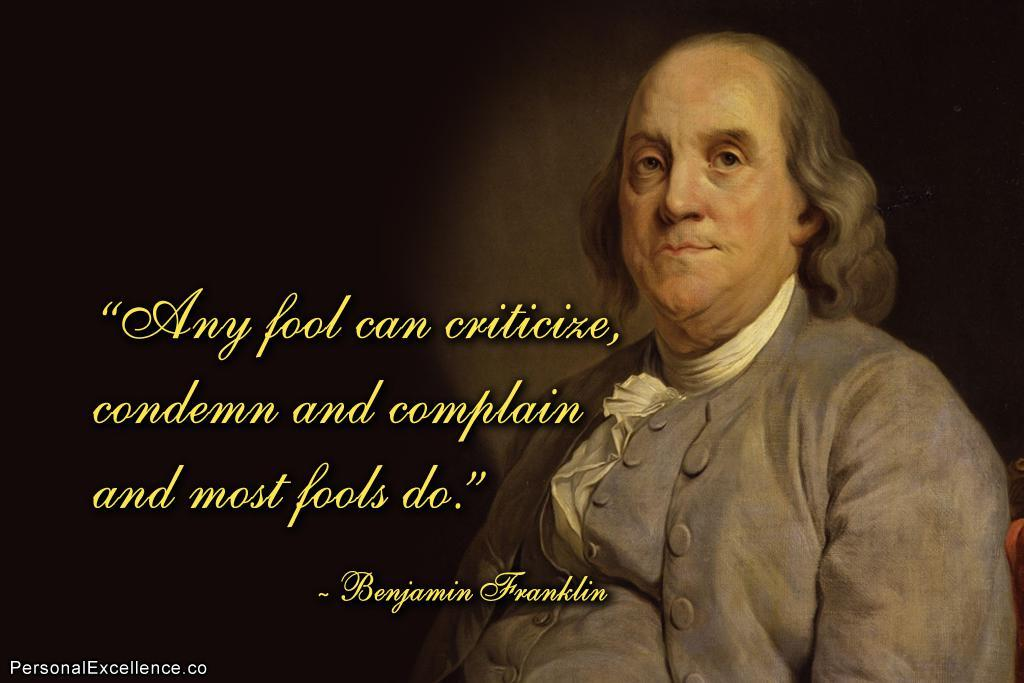What type of visual is the image? The image is a poster. What can be found on the left side of the poster? There is a quote on the left side of the poster. What is depicted on the right side of the poster? There is a man on the right side of the poster. How would you describe the overall color scheme of the poster? The background of the poster is dark. What type of face can be seen on the crook in the image? There is no crook or face present in the image; it features a quote and a man on a dark background. 